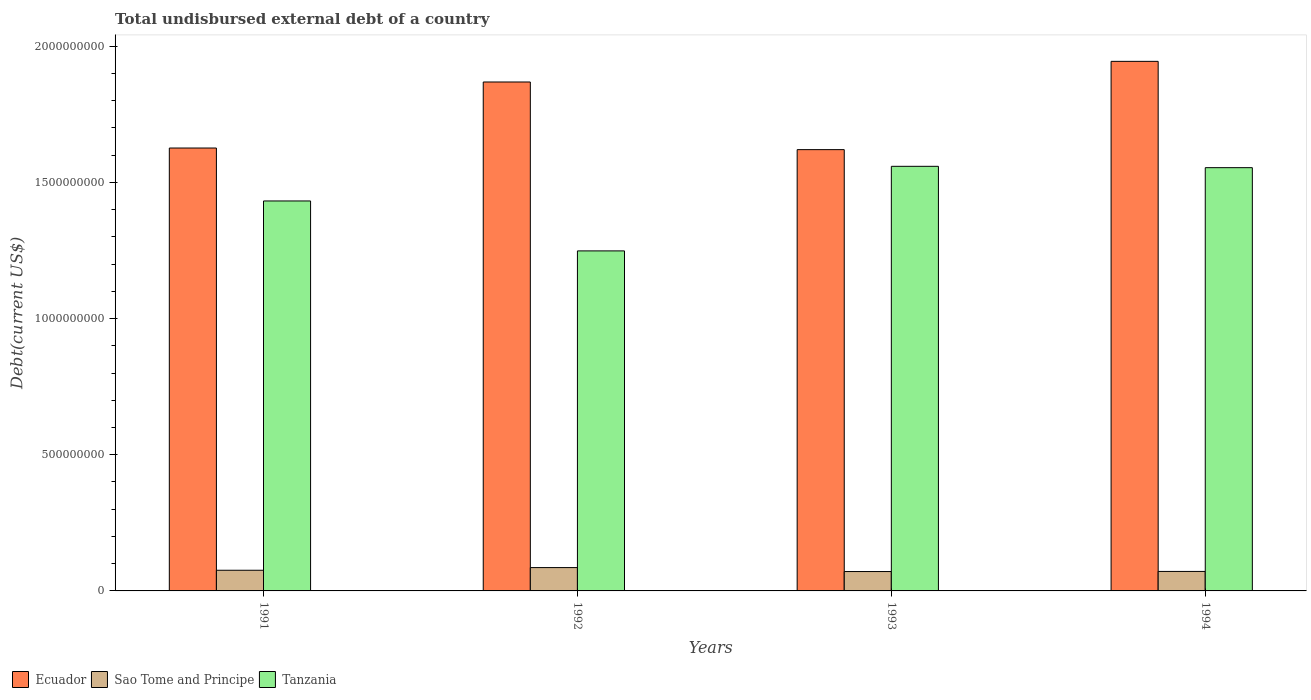How many different coloured bars are there?
Offer a very short reply. 3. How many groups of bars are there?
Your answer should be very brief. 4. Are the number of bars on each tick of the X-axis equal?
Give a very brief answer. Yes. How many bars are there on the 2nd tick from the left?
Your answer should be very brief. 3. What is the label of the 2nd group of bars from the left?
Provide a short and direct response. 1992. In how many cases, is the number of bars for a given year not equal to the number of legend labels?
Make the answer very short. 0. What is the total undisbursed external debt in Ecuador in 1994?
Your answer should be compact. 1.94e+09. Across all years, what is the maximum total undisbursed external debt in Ecuador?
Keep it short and to the point. 1.94e+09. Across all years, what is the minimum total undisbursed external debt in Tanzania?
Offer a terse response. 1.25e+09. In which year was the total undisbursed external debt in Tanzania maximum?
Offer a very short reply. 1993. What is the total total undisbursed external debt in Ecuador in the graph?
Offer a very short reply. 7.06e+09. What is the difference between the total undisbursed external debt in Sao Tome and Principe in 1992 and that in 1994?
Keep it short and to the point. 1.41e+07. What is the difference between the total undisbursed external debt in Sao Tome and Principe in 1993 and the total undisbursed external debt in Ecuador in 1991?
Provide a succinct answer. -1.56e+09. What is the average total undisbursed external debt in Ecuador per year?
Provide a short and direct response. 1.77e+09. In the year 1994, what is the difference between the total undisbursed external debt in Ecuador and total undisbursed external debt in Tanzania?
Your response must be concise. 3.90e+08. In how many years, is the total undisbursed external debt in Sao Tome and Principe greater than 1000000000 US$?
Ensure brevity in your answer.  0. What is the ratio of the total undisbursed external debt in Tanzania in 1993 to that in 1994?
Offer a terse response. 1. Is the total undisbursed external debt in Ecuador in 1992 less than that in 1994?
Your answer should be very brief. Yes. Is the difference between the total undisbursed external debt in Ecuador in 1991 and 1994 greater than the difference between the total undisbursed external debt in Tanzania in 1991 and 1994?
Ensure brevity in your answer.  No. What is the difference between the highest and the second highest total undisbursed external debt in Tanzania?
Offer a very short reply. 4.94e+06. What is the difference between the highest and the lowest total undisbursed external debt in Tanzania?
Make the answer very short. 3.11e+08. What does the 1st bar from the left in 1991 represents?
Your response must be concise. Ecuador. What does the 2nd bar from the right in 1991 represents?
Keep it short and to the point. Sao Tome and Principe. How many bars are there?
Offer a very short reply. 12. Are all the bars in the graph horizontal?
Offer a very short reply. No. How many years are there in the graph?
Your answer should be very brief. 4. Are the values on the major ticks of Y-axis written in scientific E-notation?
Your answer should be compact. No. Does the graph contain grids?
Ensure brevity in your answer.  No. Where does the legend appear in the graph?
Offer a very short reply. Bottom left. How many legend labels are there?
Offer a terse response. 3. What is the title of the graph?
Your answer should be compact. Total undisbursed external debt of a country. Does "Ghana" appear as one of the legend labels in the graph?
Your answer should be very brief. No. What is the label or title of the Y-axis?
Your answer should be very brief. Debt(current US$). What is the Debt(current US$) of Ecuador in 1991?
Offer a terse response. 1.63e+09. What is the Debt(current US$) of Sao Tome and Principe in 1991?
Your answer should be compact. 7.59e+07. What is the Debt(current US$) in Tanzania in 1991?
Provide a succinct answer. 1.43e+09. What is the Debt(current US$) of Ecuador in 1992?
Your answer should be compact. 1.87e+09. What is the Debt(current US$) in Sao Tome and Principe in 1992?
Make the answer very short. 8.57e+07. What is the Debt(current US$) of Tanzania in 1992?
Your answer should be compact. 1.25e+09. What is the Debt(current US$) of Ecuador in 1993?
Give a very brief answer. 1.62e+09. What is the Debt(current US$) in Sao Tome and Principe in 1993?
Offer a very short reply. 7.11e+07. What is the Debt(current US$) in Tanzania in 1993?
Your answer should be compact. 1.56e+09. What is the Debt(current US$) in Ecuador in 1994?
Your answer should be compact. 1.94e+09. What is the Debt(current US$) of Sao Tome and Principe in 1994?
Your answer should be very brief. 7.16e+07. What is the Debt(current US$) of Tanzania in 1994?
Your response must be concise. 1.55e+09. Across all years, what is the maximum Debt(current US$) of Ecuador?
Keep it short and to the point. 1.94e+09. Across all years, what is the maximum Debt(current US$) in Sao Tome and Principe?
Offer a terse response. 8.57e+07. Across all years, what is the maximum Debt(current US$) of Tanzania?
Provide a short and direct response. 1.56e+09. Across all years, what is the minimum Debt(current US$) of Ecuador?
Your answer should be very brief. 1.62e+09. Across all years, what is the minimum Debt(current US$) in Sao Tome and Principe?
Make the answer very short. 7.11e+07. Across all years, what is the minimum Debt(current US$) of Tanzania?
Provide a succinct answer. 1.25e+09. What is the total Debt(current US$) in Ecuador in the graph?
Provide a succinct answer. 7.06e+09. What is the total Debt(current US$) of Sao Tome and Principe in the graph?
Keep it short and to the point. 3.04e+08. What is the total Debt(current US$) in Tanzania in the graph?
Your response must be concise. 5.79e+09. What is the difference between the Debt(current US$) in Ecuador in 1991 and that in 1992?
Offer a very short reply. -2.42e+08. What is the difference between the Debt(current US$) of Sao Tome and Principe in 1991 and that in 1992?
Make the answer very short. -9.82e+06. What is the difference between the Debt(current US$) of Tanzania in 1991 and that in 1992?
Your answer should be very brief. 1.83e+08. What is the difference between the Debt(current US$) in Ecuador in 1991 and that in 1993?
Your answer should be compact. 5.92e+06. What is the difference between the Debt(current US$) in Sao Tome and Principe in 1991 and that in 1993?
Make the answer very short. 4.75e+06. What is the difference between the Debt(current US$) of Tanzania in 1991 and that in 1993?
Ensure brevity in your answer.  -1.27e+08. What is the difference between the Debt(current US$) in Ecuador in 1991 and that in 1994?
Your response must be concise. -3.18e+08. What is the difference between the Debt(current US$) in Sao Tome and Principe in 1991 and that in 1994?
Ensure brevity in your answer.  4.30e+06. What is the difference between the Debt(current US$) of Tanzania in 1991 and that in 1994?
Offer a terse response. -1.22e+08. What is the difference between the Debt(current US$) of Ecuador in 1992 and that in 1993?
Your response must be concise. 2.48e+08. What is the difference between the Debt(current US$) in Sao Tome and Principe in 1992 and that in 1993?
Keep it short and to the point. 1.46e+07. What is the difference between the Debt(current US$) of Tanzania in 1992 and that in 1993?
Your response must be concise. -3.11e+08. What is the difference between the Debt(current US$) of Ecuador in 1992 and that in 1994?
Offer a very short reply. -7.58e+07. What is the difference between the Debt(current US$) of Sao Tome and Principe in 1992 and that in 1994?
Your answer should be very brief. 1.41e+07. What is the difference between the Debt(current US$) of Tanzania in 1992 and that in 1994?
Your answer should be very brief. -3.06e+08. What is the difference between the Debt(current US$) in Ecuador in 1993 and that in 1994?
Offer a very short reply. -3.24e+08. What is the difference between the Debt(current US$) in Sao Tome and Principe in 1993 and that in 1994?
Your answer should be compact. -4.51e+05. What is the difference between the Debt(current US$) in Tanzania in 1993 and that in 1994?
Provide a succinct answer. 4.94e+06. What is the difference between the Debt(current US$) in Ecuador in 1991 and the Debt(current US$) in Sao Tome and Principe in 1992?
Your answer should be very brief. 1.54e+09. What is the difference between the Debt(current US$) of Ecuador in 1991 and the Debt(current US$) of Tanzania in 1992?
Ensure brevity in your answer.  3.78e+08. What is the difference between the Debt(current US$) in Sao Tome and Principe in 1991 and the Debt(current US$) in Tanzania in 1992?
Offer a very short reply. -1.17e+09. What is the difference between the Debt(current US$) in Ecuador in 1991 and the Debt(current US$) in Sao Tome and Principe in 1993?
Your response must be concise. 1.56e+09. What is the difference between the Debt(current US$) of Ecuador in 1991 and the Debt(current US$) of Tanzania in 1993?
Make the answer very short. 6.72e+07. What is the difference between the Debt(current US$) of Sao Tome and Principe in 1991 and the Debt(current US$) of Tanzania in 1993?
Provide a succinct answer. -1.48e+09. What is the difference between the Debt(current US$) of Ecuador in 1991 and the Debt(current US$) of Sao Tome and Principe in 1994?
Ensure brevity in your answer.  1.55e+09. What is the difference between the Debt(current US$) in Ecuador in 1991 and the Debt(current US$) in Tanzania in 1994?
Your answer should be compact. 7.21e+07. What is the difference between the Debt(current US$) in Sao Tome and Principe in 1991 and the Debt(current US$) in Tanzania in 1994?
Keep it short and to the point. -1.48e+09. What is the difference between the Debt(current US$) of Ecuador in 1992 and the Debt(current US$) of Sao Tome and Principe in 1993?
Ensure brevity in your answer.  1.80e+09. What is the difference between the Debt(current US$) of Ecuador in 1992 and the Debt(current US$) of Tanzania in 1993?
Ensure brevity in your answer.  3.10e+08. What is the difference between the Debt(current US$) of Sao Tome and Principe in 1992 and the Debt(current US$) of Tanzania in 1993?
Your response must be concise. -1.47e+09. What is the difference between the Debt(current US$) in Ecuador in 1992 and the Debt(current US$) in Sao Tome and Principe in 1994?
Your response must be concise. 1.80e+09. What is the difference between the Debt(current US$) in Ecuador in 1992 and the Debt(current US$) in Tanzania in 1994?
Ensure brevity in your answer.  3.15e+08. What is the difference between the Debt(current US$) of Sao Tome and Principe in 1992 and the Debt(current US$) of Tanzania in 1994?
Offer a very short reply. -1.47e+09. What is the difference between the Debt(current US$) in Ecuador in 1993 and the Debt(current US$) in Sao Tome and Principe in 1994?
Ensure brevity in your answer.  1.55e+09. What is the difference between the Debt(current US$) of Ecuador in 1993 and the Debt(current US$) of Tanzania in 1994?
Your answer should be very brief. 6.62e+07. What is the difference between the Debt(current US$) in Sao Tome and Principe in 1993 and the Debt(current US$) in Tanzania in 1994?
Give a very brief answer. -1.48e+09. What is the average Debt(current US$) of Ecuador per year?
Your response must be concise. 1.77e+09. What is the average Debt(current US$) of Sao Tome and Principe per year?
Ensure brevity in your answer.  7.61e+07. What is the average Debt(current US$) of Tanzania per year?
Offer a terse response. 1.45e+09. In the year 1991, what is the difference between the Debt(current US$) of Ecuador and Debt(current US$) of Sao Tome and Principe?
Offer a terse response. 1.55e+09. In the year 1991, what is the difference between the Debt(current US$) in Ecuador and Debt(current US$) in Tanzania?
Give a very brief answer. 1.94e+08. In the year 1991, what is the difference between the Debt(current US$) in Sao Tome and Principe and Debt(current US$) in Tanzania?
Ensure brevity in your answer.  -1.36e+09. In the year 1992, what is the difference between the Debt(current US$) of Ecuador and Debt(current US$) of Sao Tome and Principe?
Offer a very short reply. 1.78e+09. In the year 1992, what is the difference between the Debt(current US$) of Ecuador and Debt(current US$) of Tanzania?
Offer a very short reply. 6.20e+08. In the year 1992, what is the difference between the Debt(current US$) in Sao Tome and Principe and Debt(current US$) in Tanzania?
Offer a very short reply. -1.16e+09. In the year 1993, what is the difference between the Debt(current US$) of Ecuador and Debt(current US$) of Sao Tome and Principe?
Your answer should be very brief. 1.55e+09. In the year 1993, what is the difference between the Debt(current US$) of Ecuador and Debt(current US$) of Tanzania?
Your answer should be very brief. 6.13e+07. In the year 1993, what is the difference between the Debt(current US$) of Sao Tome and Principe and Debt(current US$) of Tanzania?
Ensure brevity in your answer.  -1.49e+09. In the year 1994, what is the difference between the Debt(current US$) of Ecuador and Debt(current US$) of Sao Tome and Principe?
Your response must be concise. 1.87e+09. In the year 1994, what is the difference between the Debt(current US$) of Ecuador and Debt(current US$) of Tanzania?
Provide a short and direct response. 3.90e+08. In the year 1994, what is the difference between the Debt(current US$) of Sao Tome and Principe and Debt(current US$) of Tanzania?
Your answer should be compact. -1.48e+09. What is the ratio of the Debt(current US$) of Ecuador in 1991 to that in 1992?
Ensure brevity in your answer.  0.87. What is the ratio of the Debt(current US$) of Sao Tome and Principe in 1991 to that in 1992?
Your answer should be very brief. 0.89. What is the ratio of the Debt(current US$) of Tanzania in 1991 to that in 1992?
Provide a succinct answer. 1.15. What is the ratio of the Debt(current US$) in Ecuador in 1991 to that in 1993?
Make the answer very short. 1. What is the ratio of the Debt(current US$) in Sao Tome and Principe in 1991 to that in 1993?
Your response must be concise. 1.07. What is the ratio of the Debt(current US$) in Tanzania in 1991 to that in 1993?
Give a very brief answer. 0.92. What is the ratio of the Debt(current US$) of Ecuador in 1991 to that in 1994?
Ensure brevity in your answer.  0.84. What is the ratio of the Debt(current US$) in Sao Tome and Principe in 1991 to that in 1994?
Provide a short and direct response. 1.06. What is the ratio of the Debt(current US$) of Tanzania in 1991 to that in 1994?
Make the answer very short. 0.92. What is the ratio of the Debt(current US$) of Ecuador in 1992 to that in 1993?
Provide a succinct answer. 1.15. What is the ratio of the Debt(current US$) in Sao Tome and Principe in 1992 to that in 1993?
Give a very brief answer. 1.2. What is the ratio of the Debt(current US$) of Tanzania in 1992 to that in 1993?
Offer a terse response. 0.8. What is the ratio of the Debt(current US$) in Ecuador in 1992 to that in 1994?
Offer a very short reply. 0.96. What is the ratio of the Debt(current US$) of Sao Tome and Principe in 1992 to that in 1994?
Offer a terse response. 1.2. What is the ratio of the Debt(current US$) in Tanzania in 1992 to that in 1994?
Offer a very short reply. 0.8. What is the difference between the highest and the second highest Debt(current US$) in Ecuador?
Provide a succinct answer. 7.58e+07. What is the difference between the highest and the second highest Debt(current US$) of Sao Tome and Principe?
Your answer should be compact. 9.82e+06. What is the difference between the highest and the second highest Debt(current US$) in Tanzania?
Your response must be concise. 4.94e+06. What is the difference between the highest and the lowest Debt(current US$) in Ecuador?
Offer a terse response. 3.24e+08. What is the difference between the highest and the lowest Debt(current US$) of Sao Tome and Principe?
Ensure brevity in your answer.  1.46e+07. What is the difference between the highest and the lowest Debt(current US$) in Tanzania?
Keep it short and to the point. 3.11e+08. 